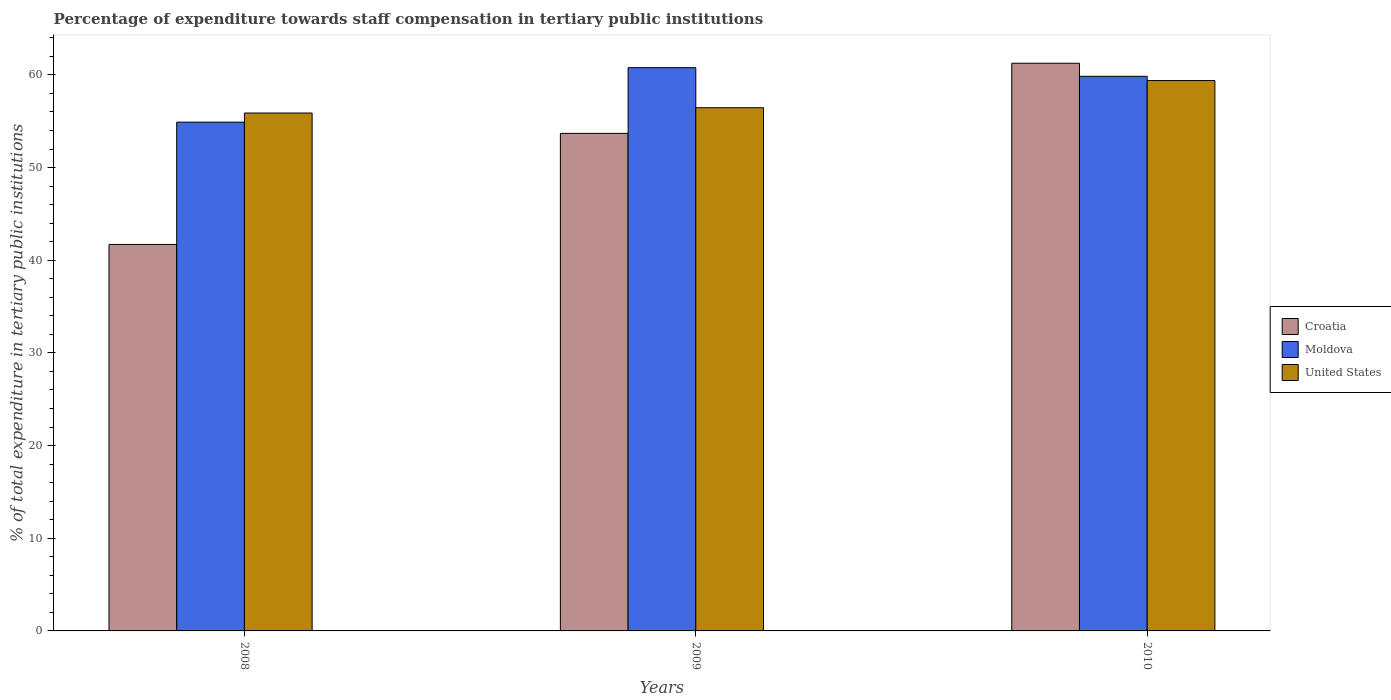How many groups of bars are there?
Offer a very short reply. 3. Are the number of bars per tick equal to the number of legend labels?
Give a very brief answer. Yes. Are the number of bars on each tick of the X-axis equal?
Your answer should be compact. Yes. How many bars are there on the 2nd tick from the right?
Your answer should be compact. 3. What is the percentage of expenditure towards staff compensation in Croatia in 2008?
Ensure brevity in your answer.  41.7. Across all years, what is the maximum percentage of expenditure towards staff compensation in United States?
Make the answer very short. 59.39. Across all years, what is the minimum percentage of expenditure towards staff compensation in United States?
Your answer should be compact. 55.88. In which year was the percentage of expenditure towards staff compensation in Croatia maximum?
Give a very brief answer. 2010. In which year was the percentage of expenditure towards staff compensation in Moldova minimum?
Give a very brief answer. 2008. What is the total percentage of expenditure towards staff compensation in United States in the graph?
Offer a terse response. 171.73. What is the difference between the percentage of expenditure towards staff compensation in Moldova in 2008 and that in 2009?
Provide a succinct answer. -5.88. What is the difference between the percentage of expenditure towards staff compensation in Moldova in 2008 and the percentage of expenditure towards staff compensation in Croatia in 2009?
Your answer should be compact. 1.21. What is the average percentage of expenditure towards staff compensation in Moldova per year?
Offer a very short reply. 58.51. In the year 2008, what is the difference between the percentage of expenditure towards staff compensation in Moldova and percentage of expenditure towards staff compensation in Croatia?
Give a very brief answer. 13.2. What is the ratio of the percentage of expenditure towards staff compensation in United States in 2009 to that in 2010?
Give a very brief answer. 0.95. Is the difference between the percentage of expenditure towards staff compensation in Moldova in 2008 and 2009 greater than the difference between the percentage of expenditure towards staff compensation in Croatia in 2008 and 2009?
Your response must be concise. Yes. What is the difference between the highest and the second highest percentage of expenditure towards staff compensation in Croatia?
Your answer should be very brief. 7.57. What is the difference between the highest and the lowest percentage of expenditure towards staff compensation in Croatia?
Give a very brief answer. 19.55. In how many years, is the percentage of expenditure towards staff compensation in Croatia greater than the average percentage of expenditure towards staff compensation in Croatia taken over all years?
Your response must be concise. 2. What does the 2nd bar from the left in 2010 represents?
Keep it short and to the point. Moldova. What does the 3rd bar from the right in 2010 represents?
Your answer should be compact. Croatia. How many years are there in the graph?
Give a very brief answer. 3. What is the difference between two consecutive major ticks on the Y-axis?
Offer a terse response. 10. Does the graph contain any zero values?
Keep it short and to the point. No. Does the graph contain grids?
Give a very brief answer. No. How many legend labels are there?
Offer a terse response. 3. How are the legend labels stacked?
Offer a terse response. Vertical. What is the title of the graph?
Your answer should be compact. Percentage of expenditure towards staff compensation in tertiary public institutions. What is the label or title of the X-axis?
Provide a short and direct response. Years. What is the label or title of the Y-axis?
Your answer should be compact. % of total expenditure in tertiary public institutions. What is the % of total expenditure in tertiary public institutions of Croatia in 2008?
Make the answer very short. 41.7. What is the % of total expenditure in tertiary public institutions of Moldova in 2008?
Your answer should be compact. 54.9. What is the % of total expenditure in tertiary public institutions in United States in 2008?
Your answer should be very brief. 55.88. What is the % of total expenditure in tertiary public institutions in Croatia in 2009?
Ensure brevity in your answer.  53.69. What is the % of total expenditure in tertiary public institutions in Moldova in 2009?
Offer a very short reply. 60.78. What is the % of total expenditure in tertiary public institutions in United States in 2009?
Ensure brevity in your answer.  56.46. What is the % of total expenditure in tertiary public institutions in Croatia in 2010?
Offer a terse response. 61.25. What is the % of total expenditure in tertiary public institutions of Moldova in 2010?
Provide a succinct answer. 59.85. What is the % of total expenditure in tertiary public institutions of United States in 2010?
Offer a terse response. 59.39. Across all years, what is the maximum % of total expenditure in tertiary public institutions in Croatia?
Make the answer very short. 61.25. Across all years, what is the maximum % of total expenditure in tertiary public institutions in Moldova?
Provide a succinct answer. 60.78. Across all years, what is the maximum % of total expenditure in tertiary public institutions in United States?
Give a very brief answer. 59.39. Across all years, what is the minimum % of total expenditure in tertiary public institutions of Croatia?
Give a very brief answer. 41.7. Across all years, what is the minimum % of total expenditure in tertiary public institutions in Moldova?
Your response must be concise. 54.9. Across all years, what is the minimum % of total expenditure in tertiary public institutions of United States?
Provide a succinct answer. 55.88. What is the total % of total expenditure in tertiary public institutions of Croatia in the graph?
Offer a very short reply. 156.64. What is the total % of total expenditure in tertiary public institutions of Moldova in the graph?
Make the answer very short. 175.52. What is the total % of total expenditure in tertiary public institutions of United States in the graph?
Provide a succinct answer. 171.73. What is the difference between the % of total expenditure in tertiary public institutions of Croatia in 2008 and that in 2009?
Your response must be concise. -11.98. What is the difference between the % of total expenditure in tertiary public institutions in Moldova in 2008 and that in 2009?
Make the answer very short. -5.88. What is the difference between the % of total expenditure in tertiary public institutions of United States in 2008 and that in 2009?
Provide a short and direct response. -0.57. What is the difference between the % of total expenditure in tertiary public institutions of Croatia in 2008 and that in 2010?
Make the answer very short. -19.55. What is the difference between the % of total expenditure in tertiary public institutions of Moldova in 2008 and that in 2010?
Make the answer very short. -4.95. What is the difference between the % of total expenditure in tertiary public institutions of United States in 2008 and that in 2010?
Ensure brevity in your answer.  -3.5. What is the difference between the % of total expenditure in tertiary public institutions of Croatia in 2009 and that in 2010?
Keep it short and to the point. -7.57. What is the difference between the % of total expenditure in tertiary public institutions of Moldova in 2009 and that in 2010?
Keep it short and to the point. 0.93. What is the difference between the % of total expenditure in tertiary public institutions of United States in 2009 and that in 2010?
Your answer should be compact. -2.93. What is the difference between the % of total expenditure in tertiary public institutions in Croatia in 2008 and the % of total expenditure in tertiary public institutions in Moldova in 2009?
Give a very brief answer. -19.07. What is the difference between the % of total expenditure in tertiary public institutions of Croatia in 2008 and the % of total expenditure in tertiary public institutions of United States in 2009?
Keep it short and to the point. -14.75. What is the difference between the % of total expenditure in tertiary public institutions in Moldova in 2008 and the % of total expenditure in tertiary public institutions in United States in 2009?
Provide a succinct answer. -1.56. What is the difference between the % of total expenditure in tertiary public institutions in Croatia in 2008 and the % of total expenditure in tertiary public institutions in Moldova in 2010?
Offer a terse response. -18.14. What is the difference between the % of total expenditure in tertiary public institutions of Croatia in 2008 and the % of total expenditure in tertiary public institutions of United States in 2010?
Make the answer very short. -17.68. What is the difference between the % of total expenditure in tertiary public institutions of Moldova in 2008 and the % of total expenditure in tertiary public institutions of United States in 2010?
Ensure brevity in your answer.  -4.49. What is the difference between the % of total expenditure in tertiary public institutions of Croatia in 2009 and the % of total expenditure in tertiary public institutions of Moldova in 2010?
Give a very brief answer. -6.16. What is the difference between the % of total expenditure in tertiary public institutions in Croatia in 2009 and the % of total expenditure in tertiary public institutions in United States in 2010?
Make the answer very short. -5.7. What is the difference between the % of total expenditure in tertiary public institutions of Moldova in 2009 and the % of total expenditure in tertiary public institutions of United States in 2010?
Your answer should be compact. 1.39. What is the average % of total expenditure in tertiary public institutions of Croatia per year?
Your answer should be compact. 52.21. What is the average % of total expenditure in tertiary public institutions of Moldova per year?
Your response must be concise. 58.51. What is the average % of total expenditure in tertiary public institutions of United States per year?
Give a very brief answer. 57.24. In the year 2008, what is the difference between the % of total expenditure in tertiary public institutions in Croatia and % of total expenditure in tertiary public institutions in Moldova?
Ensure brevity in your answer.  -13.2. In the year 2008, what is the difference between the % of total expenditure in tertiary public institutions in Croatia and % of total expenditure in tertiary public institutions in United States?
Your answer should be very brief. -14.18. In the year 2008, what is the difference between the % of total expenditure in tertiary public institutions in Moldova and % of total expenditure in tertiary public institutions in United States?
Offer a terse response. -0.99. In the year 2009, what is the difference between the % of total expenditure in tertiary public institutions in Croatia and % of total expenditure in tertiary public institutions in Moldova?
Keep it short and to the point. -7.09. In the year 2009, what is the difference between the % of total expenditure in tertiary public institutions in Croatia and % of total expenditure in tertiary public institutions in United States?
Provide a succinct answer. -2.77. In the year 2009, what is the difference between the % of total expenditure in tertiary public institutions of Moldova and % of total expenditure in tertiary public institutions of United States?
Keep it short and to the point. 4.32. In the year 2010, what is the difference between the % of total expenditure in tertiary public institutions of Croatia and % of total expenditure in tertiary public institutions of Moldova?
Your response must be concise. 1.41. In the year 2010, what is the difference between the % of total expenditure in tertiary public institutions of Croatia and % of total expenditure in tertiary public institutions of United States?
Give a very brief answer. 1.87. In the year 2010, what is the difference between the % of total expenditure in tertiary public institutions in Moldova and % of total expenditure in tertiary public institutions in United States?
Your answer should be compact. 0.46. What is the ratio of the % of total expenditure in tertiary public institutions of Croatia in 2008 to that in 2009?
Give a very brief answer. 0.78. What is the ratio of the % of total expenditure in tertiary public institutions of Moldova in 2008 to that in 2009?
Give a very brief answer. 0.9. What is the ratio of the % of total expenditure in tertiary public institutions of United States in 2008 to that in 2009?
Provide a succinct answer. 0.99. What is the ratio of the % of total expenditure in tertiary public institutions of Croatia in 2008 to that in 2010?
Keep it short and to the point. 0.68. What is the ratio of the % of total expenditure in tertiary public institutions of Moldova in 2008 to that in 2010?
Provide a succinct answer. 0.92. What is the ratio of the % of total expenditure in tertiary public institutions of United States in 2008 to that in 2010?
Make the answer very short. 0.94. What is the ratio of the % of total expenditure in tertiary public institutions of Croatia in 2009 to that in 2010?
Provide a succinct answer. 0.88. What is the ratio of the % of total expenditure in tertiary public institutions in Moldova in 2009 to that in 2010?
Provide a short and direct response. 1.02. What is the ratio of the % of total expenditure in tertiary public institutions of United States in 2009 to that in 2010?
Keep it short and to the point. 0.95. What is the difference between the highest and the second highest % of total expenditure in tertiary public institutions in Croatia?
Offer a very short reply. 7.57. What is the difference between the highest and the second highest % of total expenditure in tertiary public institutions in Moldova?
Keep it short and to the point. 0.93. What is the difference between the highest and the second highest % of total expenditure in tertiary public institutions of United States?
Your response must be concise. 2.93. What is the difference between the highest and the lowest % of total expenditure in tertiary public institutions in Croatia?
Your answer should be very brief. 19.55. What is the difference between the highest and the lowest % of total expenditure in tertiary public institutions in Moldova?
Provide a short and direct response. 5.88. What is the difference between the highest and the lowest % of total expenditure in tertiary public institutions of United States?
Keep it short and to the point. 3.5. 